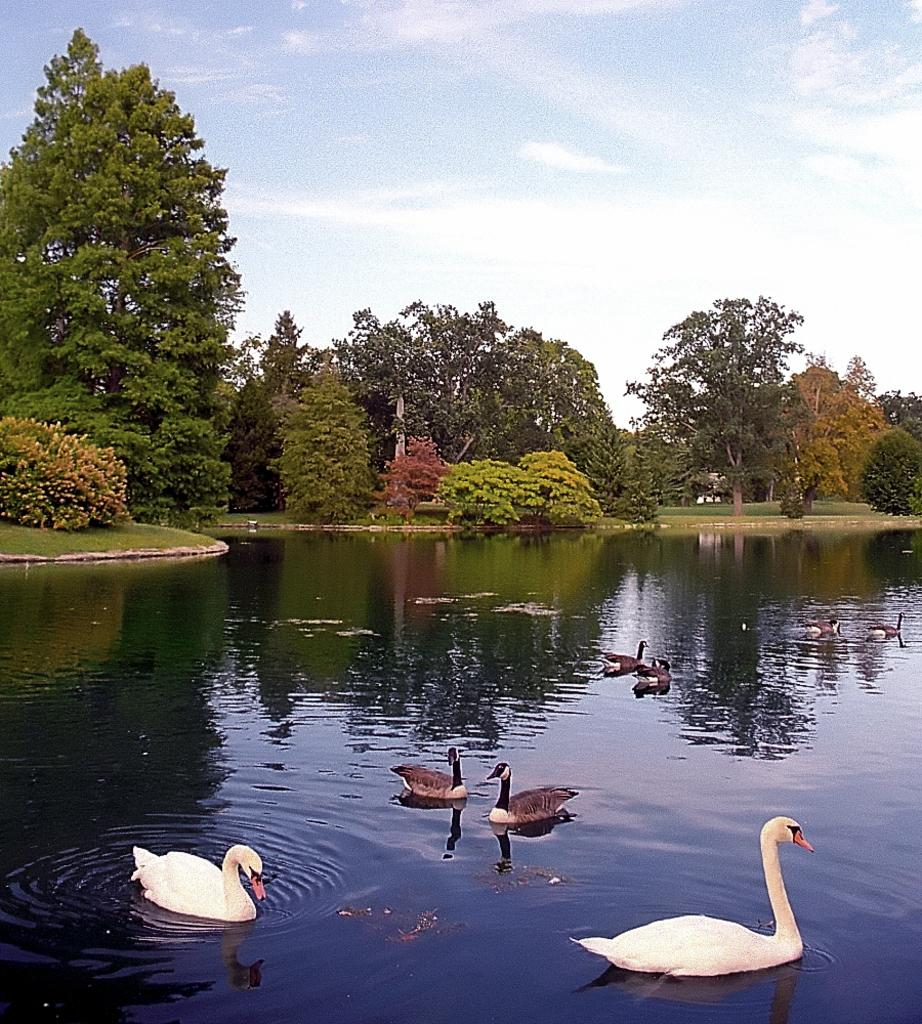What type of animals can be seen in the image? There are birds in the image. Where are the birds located? The birds are on the water. What can be seen in the background of the image? There is grass, trees, and the sky visible in the background of the image. What type of nose can be seen on the birds in the image? There is no nose present in the image, as the image features birds on the water. 